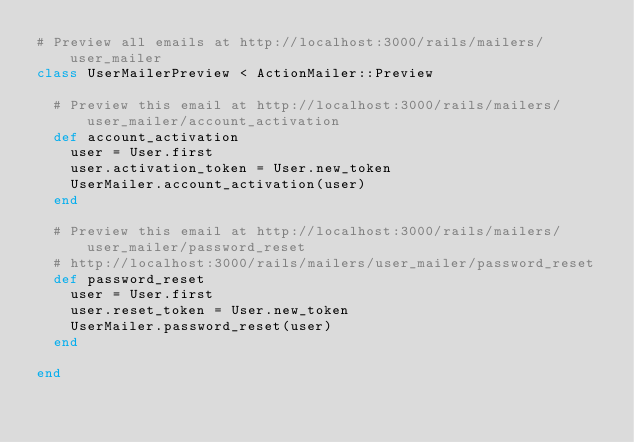Convert code to text. <code><loc_0><loc_0><loc_500><loc_500><_Ruby_># Preview all emails at http://localhost:3000/rails/mailers/user_mailer
class UserMailerPreview < ActionMailer::Preview

  # Preview this email at http://localhost:3000/rails/mailers/user_mailer/account_activation
  def account_activation
    user = User.first
    user.activation_token = User.new_token
    UserMailer.account_activation(user)
  end

  # Preview this email at http://localhost:3000/rails/mailers/user_mailer/password_reset
  # http://localhost:3000/rails/mailers/user_mailer/password_reset
  def password_reset
    user = User.first
    user.reset_token = User.new_token
    UserMailer.password_reset(user)
  end

end
</code> 